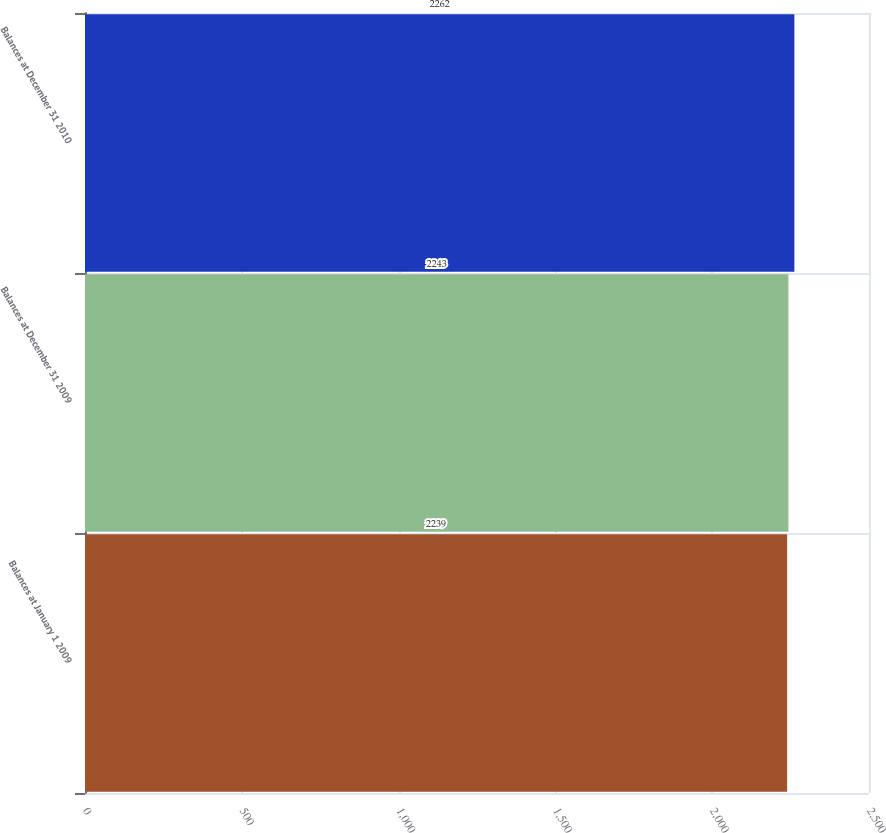<chart> <loc_0><loc_0><loc_500><loc_500><bar_chart><fcel>Balances at January 1 2009<fcel>Balances at December 31 2009<fcel>Balances at December 31 2010<nl><fcel>2239<fcel>2243<fcel>2262<nl></chart> 